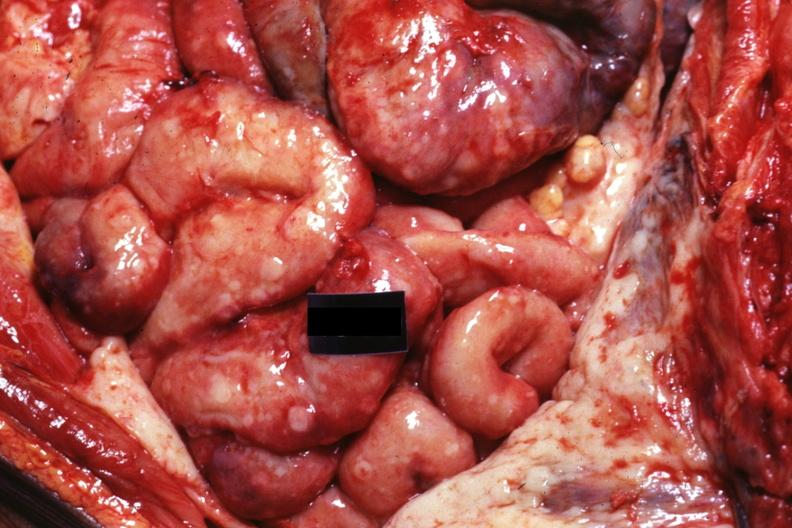what is present?
Answer the question using a single word or phrase. Abdomen 